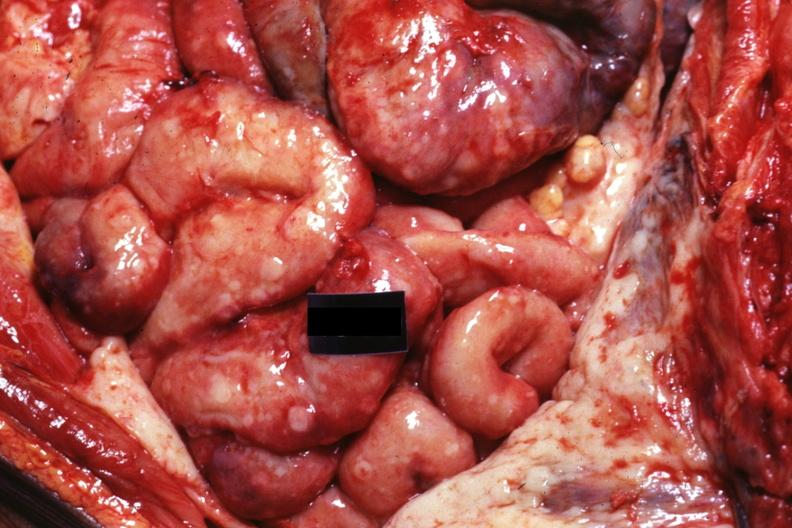what is present?
Answer the question using a single word or phrase. Abdomen 